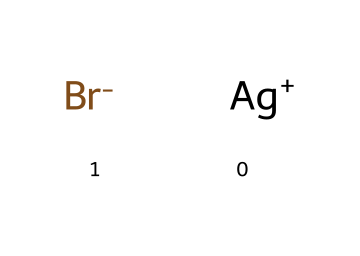What is the name of this chemical? The SMILES representation provided indicates the presence of silver (Ag) and bromine (Br) ions, which together form silver bromide. This is a common photoreactive chemical.
Answer: silver bromide How many different elements are in this chemical? The SMILES notation indicates two unique elements: silver (Ag) and bromine (Br). Therefore, the count of distinct elements is based on the unique atomic symbols present.
Answer: two How many atoms are present in this chemical structure? The SMILES notation has one silver atom and one bromine atom, leading to a total atom count of two in silver bromide.
Answer: two What type of bonding is present in this chemical? The SMILES representation indicates ionic bonding between the positively charged silver ion (Ag+) and negatively charged bromide ion (Br-). This type of bonding is characteristic of compounds formed between metals and nonmetals.
Answer: ionic Is this chemical photoreactive? Silver bromide is known for its photoreactive properties and is commonly used in photographic processes, where it responds to light exposure.
Answer: yes What is the charge of the silver ion? The SMILES provided shows a notation for silver as [Ag+], indicating it carries a positive charge of +1.
Answer: +1 What is the role of bromine in this chemical? Bromine acts as the anion in the compound, providing the negative charge needed to balance the positive charge of the silver ion, thus contributing to its ionic structure.
Answer: anion 